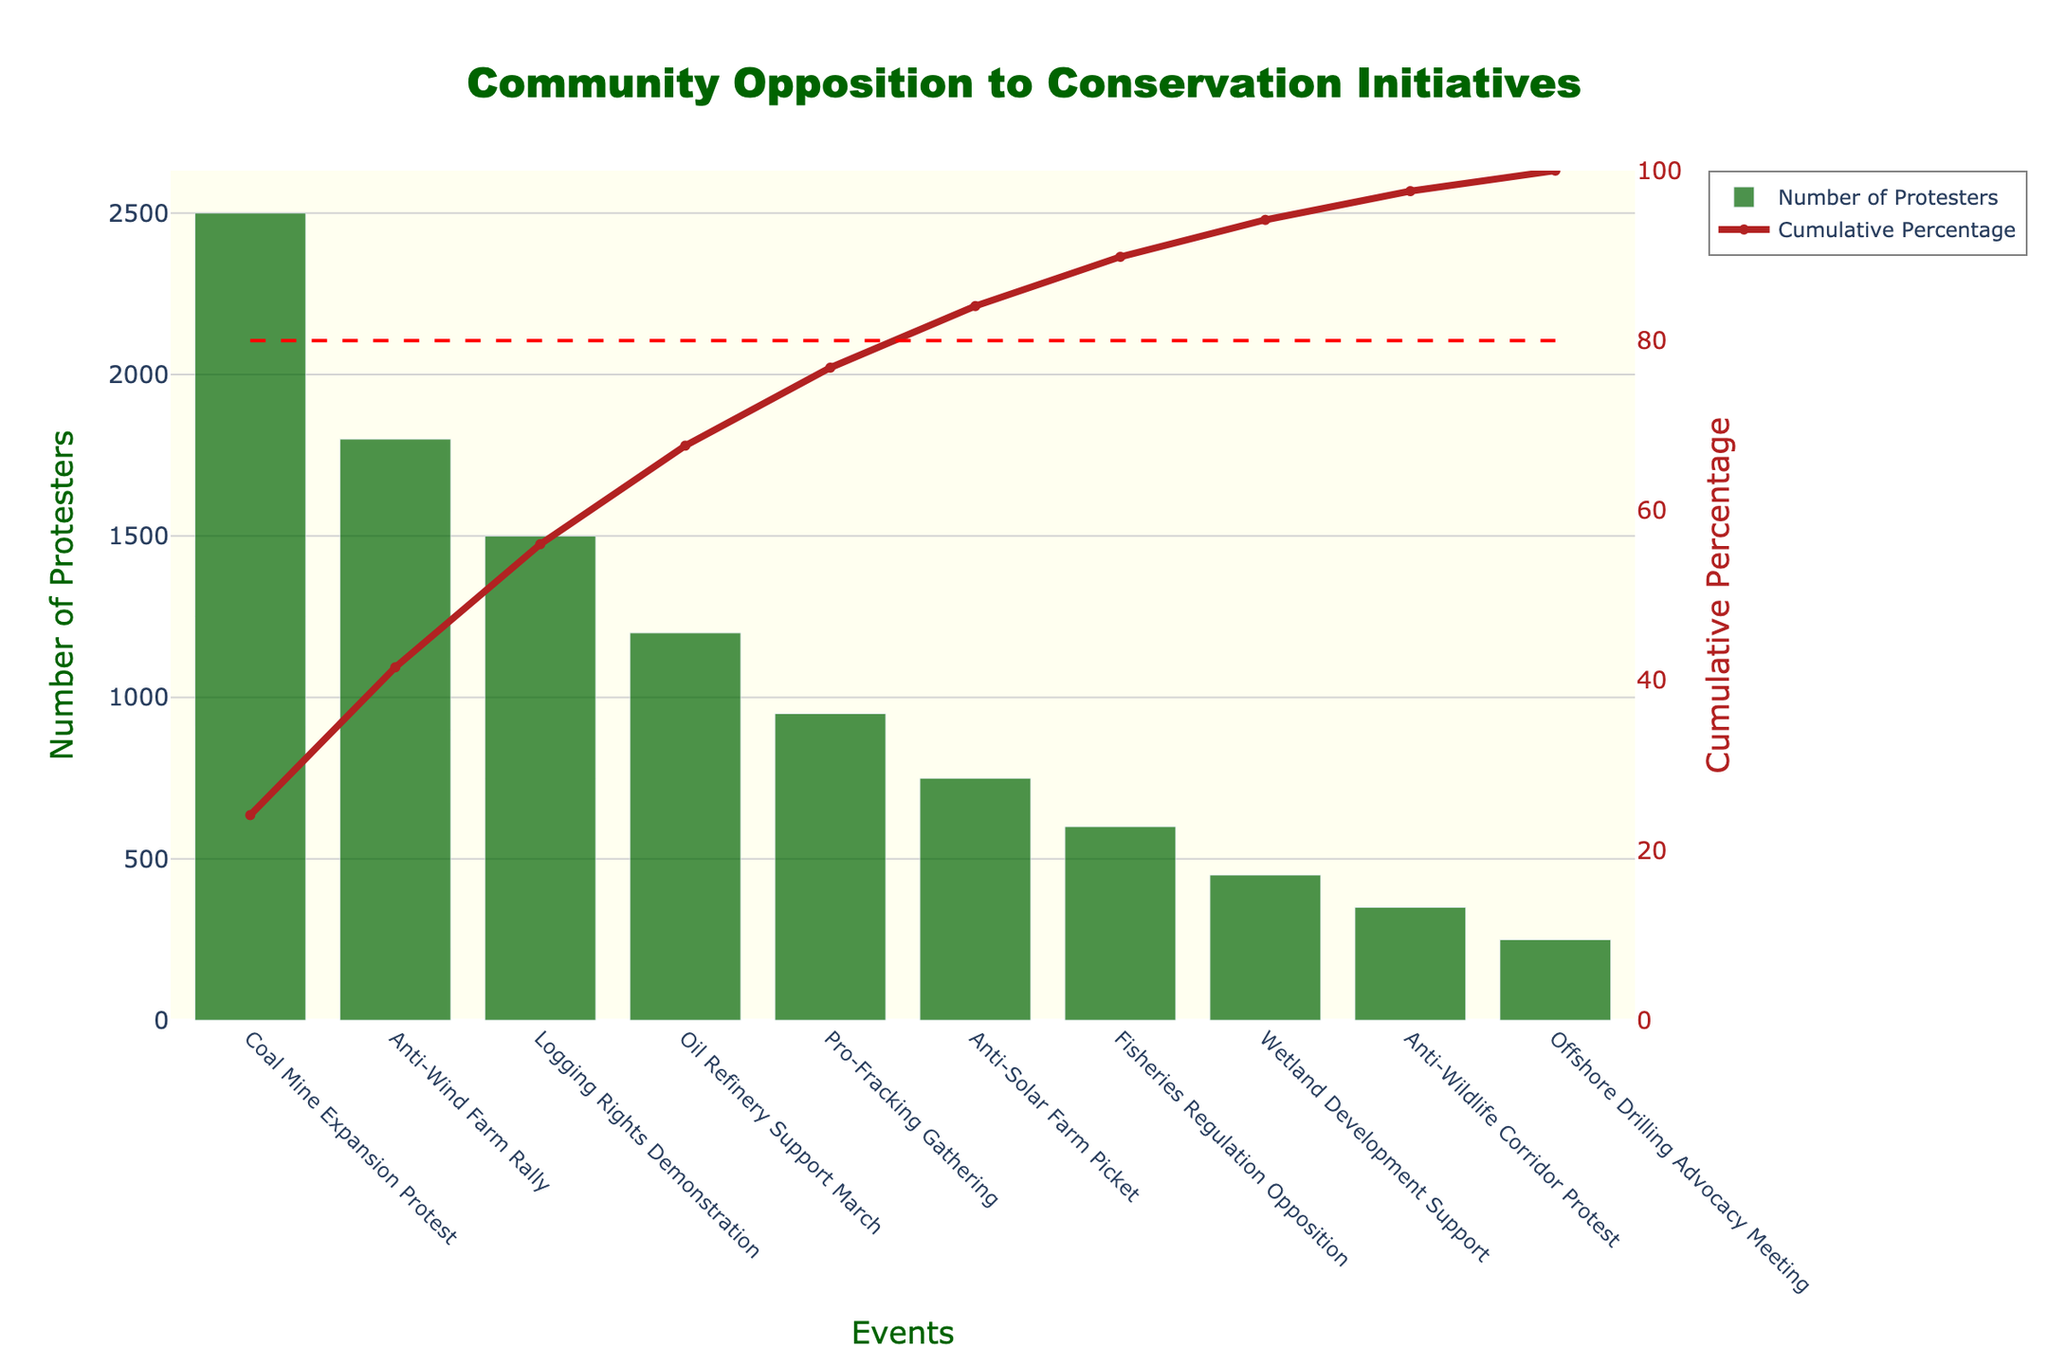What is the title of the figure? The title is located at the top of the figure and is "Community Opposition to Conservation Initiatives" with a specific font and color.
Answer: Community Opposition to Conservation Initiatives Which event had the highest number of protesters? By looking at the bar chart, the tallest bar corresponds to the "Coal Mine Expansion Protest".
Answer: Coal Mine Expansion Protest What is the cumulative percentage for the "Logging Rights Demonstration"? Find the position of the "Logging Rights Demonstration" on the x-axis and look for the corresponding value on the cumulative percentage line, it shows about 72.7%.
Answer: 72.7% How many protesters attended the "Anti-Wind Farm Rally"? The height of the bar for "Anti-Wind Farm Rally" shows about 1800 protesters.
Answer: 1800 What is the combined number of protesters for the "Anti-Solar Farm Picket" and the "Fisheries Regulation Opposition"? Sum the number of protesters for both events: 750 + 600 = 1350.
Answer: 1350 Which event contributes to reaching the 80% cumulative percentage threshold? The horizontal red dashed line at 80% crosses the cumulative percentage line after the "Logging Rights Demonstration".
Answer: Logging Rights Demonstration How many events drew fewer than 500 protesters? Count the number of bars representing less than 500 protesters: "Anti-Wildlife Corridor Protest" (350) and "Offshore Drilling Advocacy Meeting" (250), so 2 events.
Answer: 2 What percentage of the total protesters attended the "Coal Mine Expansion Protest"? To find this, calculate (Number of Protesters at "Coal Mine Expansion Protest" / Total Number of Protesters) * 100. Thus, (2500 / 11350) * 100 ≈ 22%.
Answer: 22% Which event has the smallest number of protesters and how many? The shortest bar corresponds to the "Offshore Drilling Advocacy Meeting" with 250 protesters.
Answer: Offshore Drilling Advocacy Meeting, 250 How many events have a cumulative percentage below 50%? Identify events whose cumulative percentage is below the 50% mark: "Coal Mine Expansion Protest" and "Anti-Wind Farm Rally". So, two events.
Answer: 2 